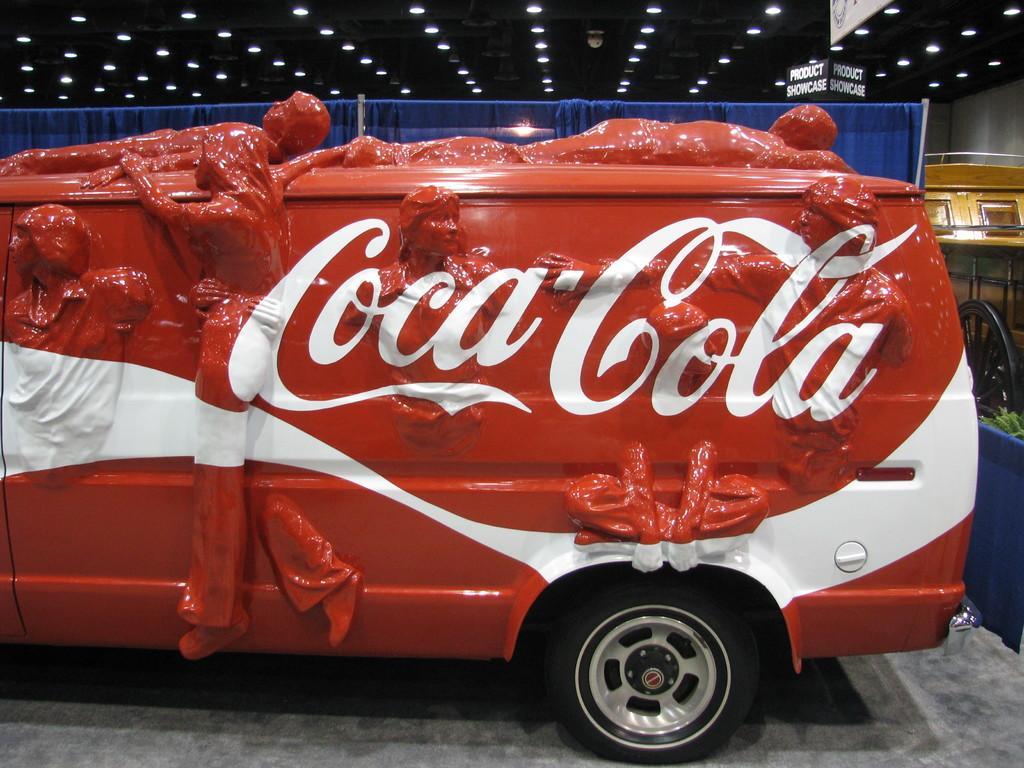In one or two sentences, can you explain what this image depicts? In the foreground of the picture there is a truck, on the truck there are sculptures of people and text. In the center of the picture there is a blue curtain. On the right there is a cart like object. At the top there are lights, board and other objects. 